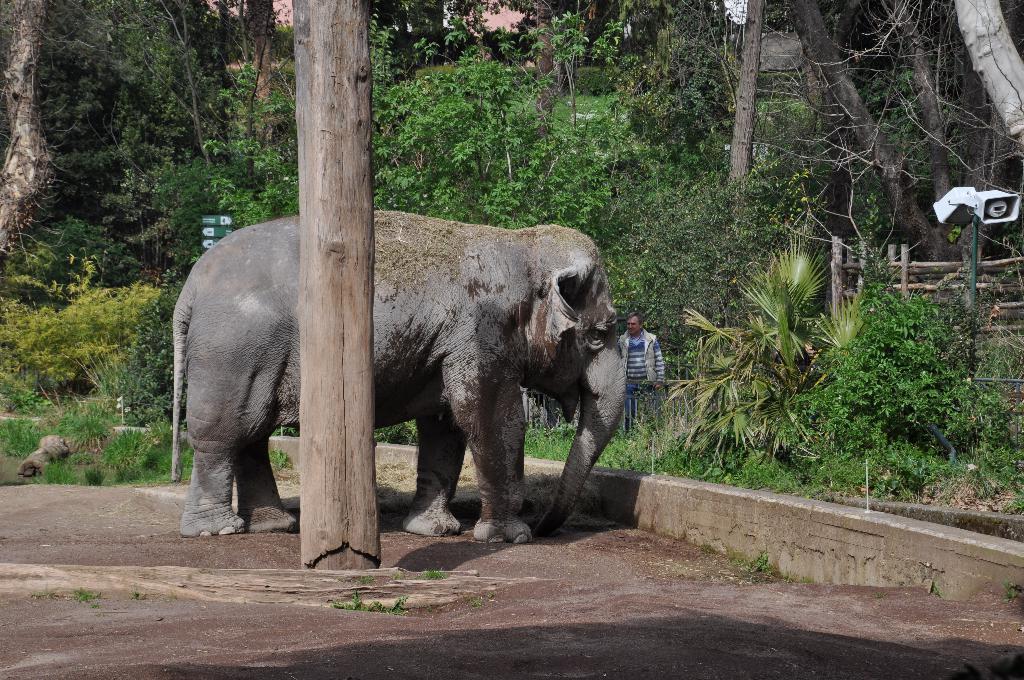Describe this image in one or two sentences. In this image I can see a elephant which is brown, ash and black in color is standing on the ground. I can see a wooden log. In the background I can see a person standing, few trees, few sign boards, a white colored objects , the wooden railing and the sky. 